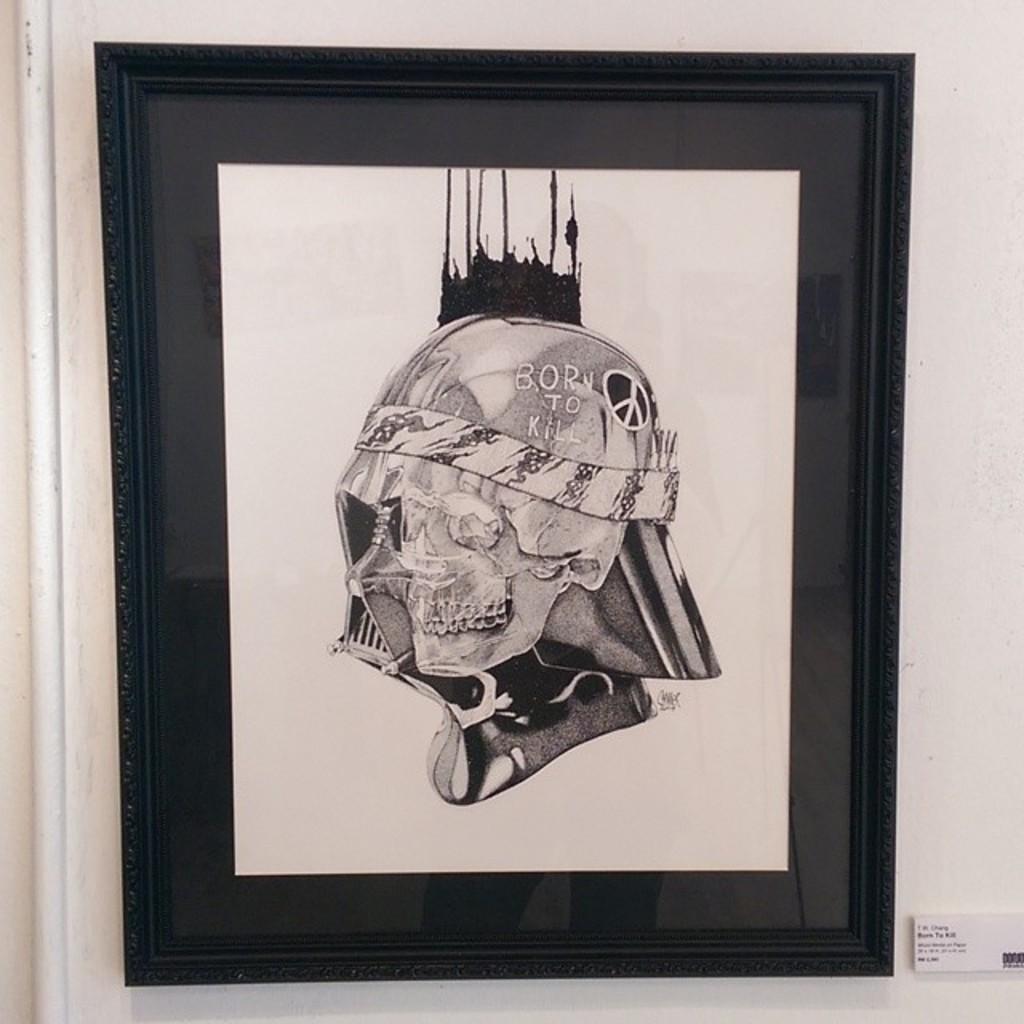Please provide a concise description of this image. In the picture we can see a black color photo frame in it we can see a painting of a skull with some designs on it and written on it as born to kill. 